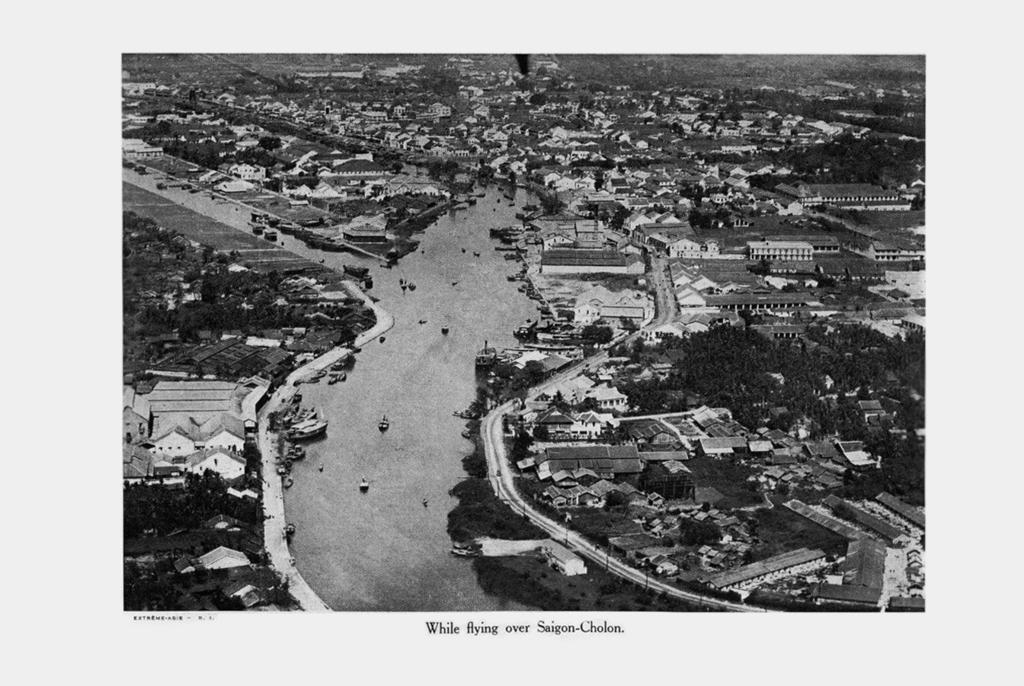Describe this image in one or two sentences. This is a black and white picture , in the picture I can see a road in the middle and I can see houses and trees visible. 